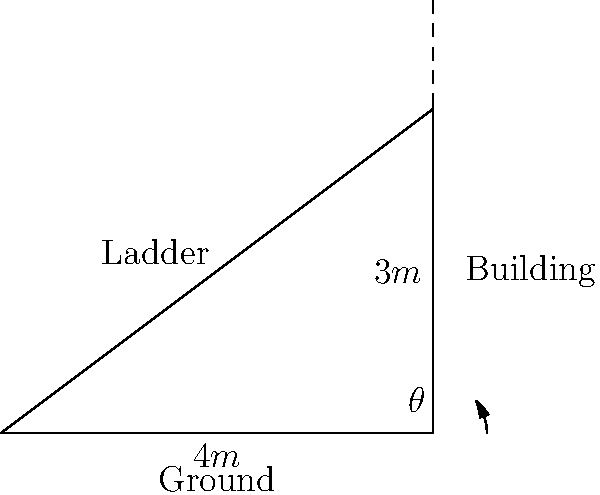As a firefighter, you need to position a ladder against a building for a rescue operation. The ladder reaches a height of 3 meters on the building and extends 4 meters from the base of the building. What is the angle (θ) between the ladder and the ground, rounded to the nearest degree? To solve this problem, we'll use trigonometry, specifically the arctangent function. Here's a step-by-step explanation:

1. Identify the right triangle formed by the ladder, building, and ground.
2. The vertical side (opposite to the angle θ) is 3 meters.
3. The horizontal side (adjacent to the angle θ) is 4 meters.
4. To find the angle θ, we use the arctangent of the opposite side divided by the adjacent side:

   $$\theta = \arctan(\frac{\text{opposite}}{\text{adjacent}})$$

5. Plugging in our values:

   $$\theta = \arctan(\frac{3}{4})$$

6. Using a calculator or trigonometric tables:

   $$\theta \approx 36.87^\circ$$

7. Rounding to the nearest degree:

   $$\theta \approx 37^\circ$$

This angle ensures a safe and stable position for the ladder during the rescue operation.
Answer: 37° 